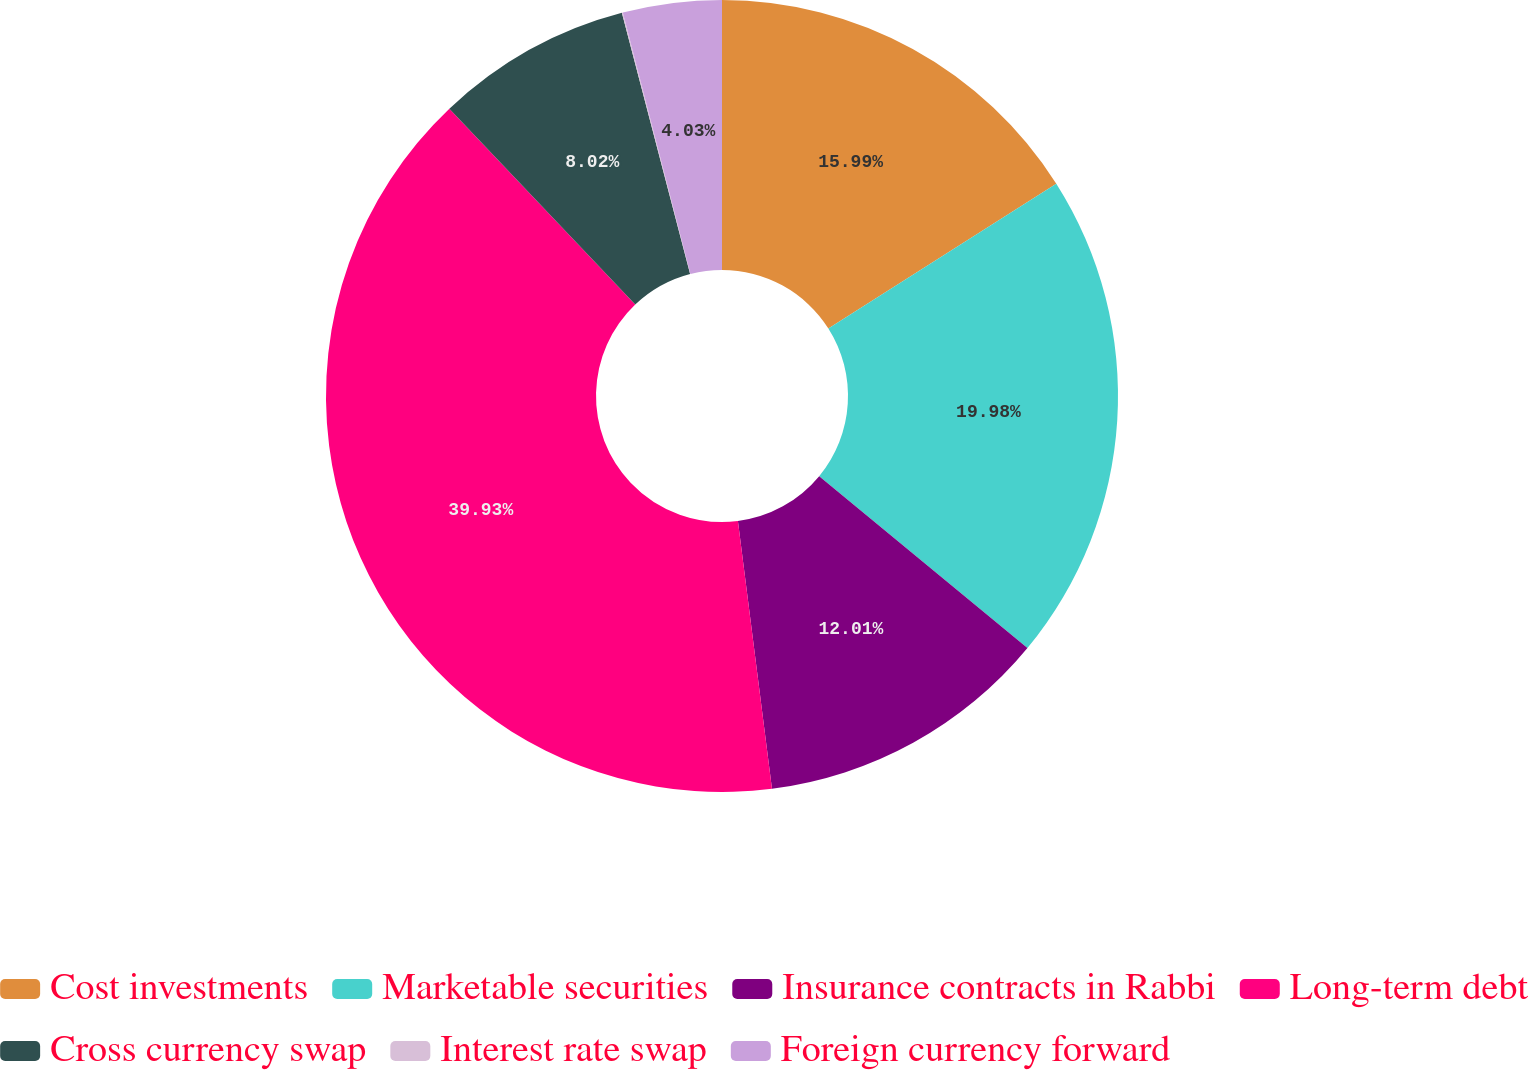Convert chart to OTSL. <chart><loc_0><loc_0><loc_500><loc_500><pie_chart><fcel>Cost investments<fcel>Marketable securities<fcel>Insurance contracts in Rabbi<fcel>Long-term debt<fcel>Cross currency swap<fcel>Interest rate swap<fcel>Foreign currency forward<nl><fcel>16.0%<fcel>19.99%<fcel>12.01%<fcel>39.94%<fcel>8.02%<fcel>0.04%<fcel>4.03%<nl></chart> 